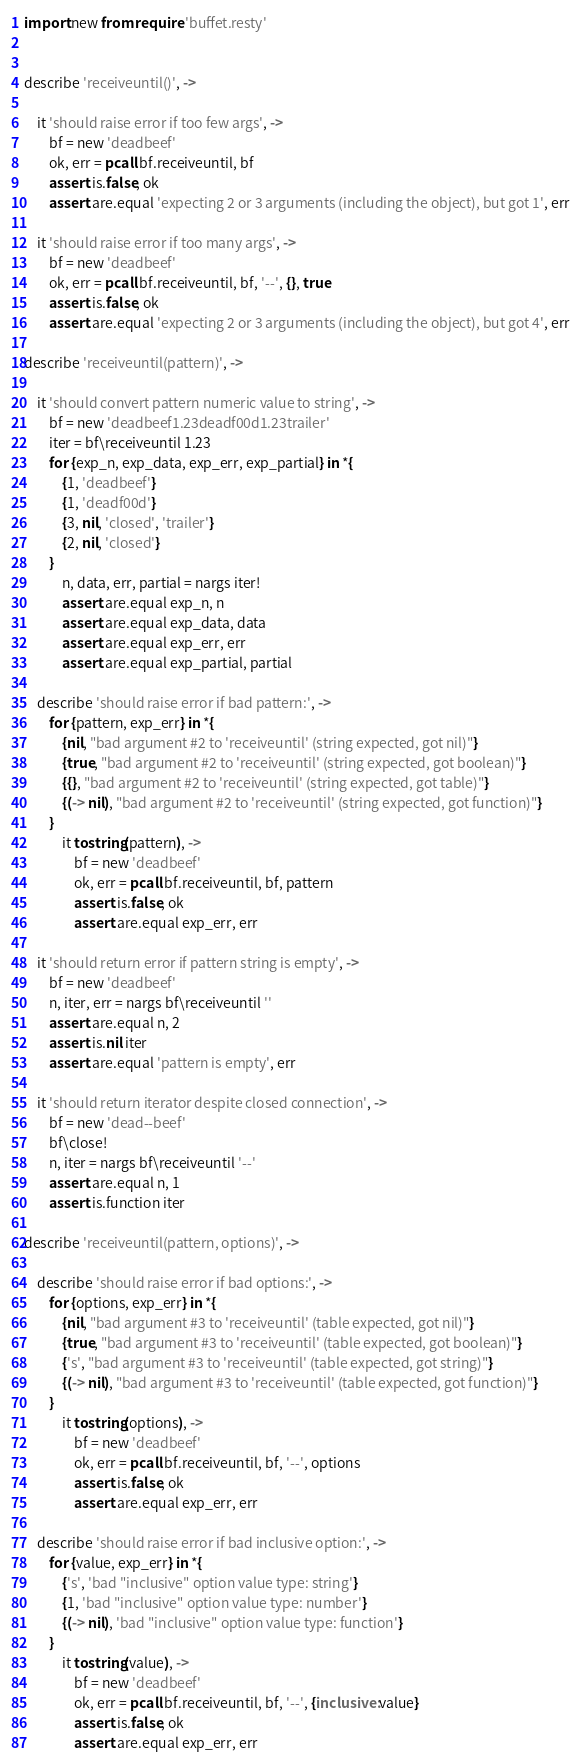Convert code to text. <code><loc_0><loc_0><loc_500><loc_500><_MoonScript_>import new from require 'buffet.resty'


describe 'receiveuntil()', ->

    it 'should raise error if too few args', ->
        bf = new 'deadbeef'
        ok, err = pcall bf.receiveuntil, bf
        assert.is.false, ok
        assert.are.equal 'expecting 2 or 3 arguments (including the object), but got 1', err

    it 'should raise error if too many args', ->
        bf = new 'deadbeef'
        ok, err = pcall bf.receiveuntil, bf, '--', {}, true
        assert.is.false, ok
        assert.are.equal 'expecting 2 or 3 arguments (including the object), but got 4', err

describe 'receiveuntil(pattern)', ->

    it 'should convert pattern numeric value to string', ->
        bf = new 'deadbeef1.23deadf00d1.23trailer'
        iter = bf\receiveuntil 1.23
        for {exp_n, exp_data, exp_err, exp_partial} in *{
            {1, 'deadbeef'}
            {1, 'deadf00d'}
            {3, nil, 'closed', 'trailer'}
            {2, nil, 'closed'}
        }
            n, data, err, partial = nargs iter!
            assert.are.equal exp_n, n
            assert.are.equal exp_data, data
            assert.are.equal exp_err, err
            assert.are.equal exp_partial, partial

    describe 'should raise error if bad pattern:', ->
        for {pattern, exp_err} in *{
            {nil, "bad argument #2 to 'receiveuntil' (string expected, got nil)"}
            {true, "bad argument #2 to 'receiveuntil' (string expected, got boolean)"}
            {{}, "bad argument #2 to 'receiveuntil' (string expected, got table)"}
            {(-> nil), "bad argument #2 to 'receiveuntil' (string expected, got function)"}
        }
            it tostring(pattern), ->
                bf = new 'deadbeef'
                ok, err = pcall bf.receiveuntil, bf, pattern
                assert.is.false, ok
                assert.are.equal exp_err, err

    it 'should return error if pattern string is empty', ->
        bf = new 'deadbeef'
        n, iter, err = nargs bf\receiveuntil ''
        assert.are.equal n, 2
        assert.is.nil iter
        assert.are.equal 'pattern is empty', err

    it 'should return iterator despite closed connection', ->
        bf = new 'dead--beef'
        bf\close!
        n, iter = nargs bf\receiveuntil '--'
        assert.are.equal n, 1
        assert.is.function iter

describe 'receiveuntil(pattern, options)', ->

    describe 'should raise error if bad options:', ->
        for {options, exp_err} in *{
            {nil, "bad argument #3 to 'receiveuntil' (table expected, got nil)"}
            {true, "bad argument #3 to 'receiveuntil' (table expected, got boolean)"}
            {'s', "bad argument #3 to 'receiveuntil' (table expected, got string)"}
            {(-> nil), "bad argument #3 to 'receiveuntil' (table expected, got function)"}
        }
            it tostring(options), ->
                bf = new 'deadbeef'
                ok, err = pcall bf.receiveuntil, bf, '--', options
                assert.is.false, ok
                assert.are.equal exp_err, err

    describe 'should raise error if bad inclusive option:', ->
        for {value, exp_err} in *{
            {'s', 'bad "inclusive" option value type: string'}
            {1, 'bad "inclusive" option value type: number'}
            {(-> nil), 'bad "inclusive" option value type: function'}
        }
            it tostring(value), ->
                bf = new 'deadbeef'
                ok, err = pcall bf.receiveuntil, bf, '--', {inclusive: value}
                assert.is.false, ok
                assert.are.equal exp_err, err
</code> 